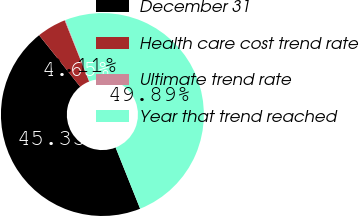Convert chart. <chart><loc_0><loc_0><loc_500><loc_500><pie_chart><fcel>December 31<fcel>Health care cost trend rate<fcel>Ultimate trend rate<fcel>Year that trend reached<nl><fcel>45.35%<fcel>4.65%<fcel>0.11%<fcel>49.89%<nl></chart> 